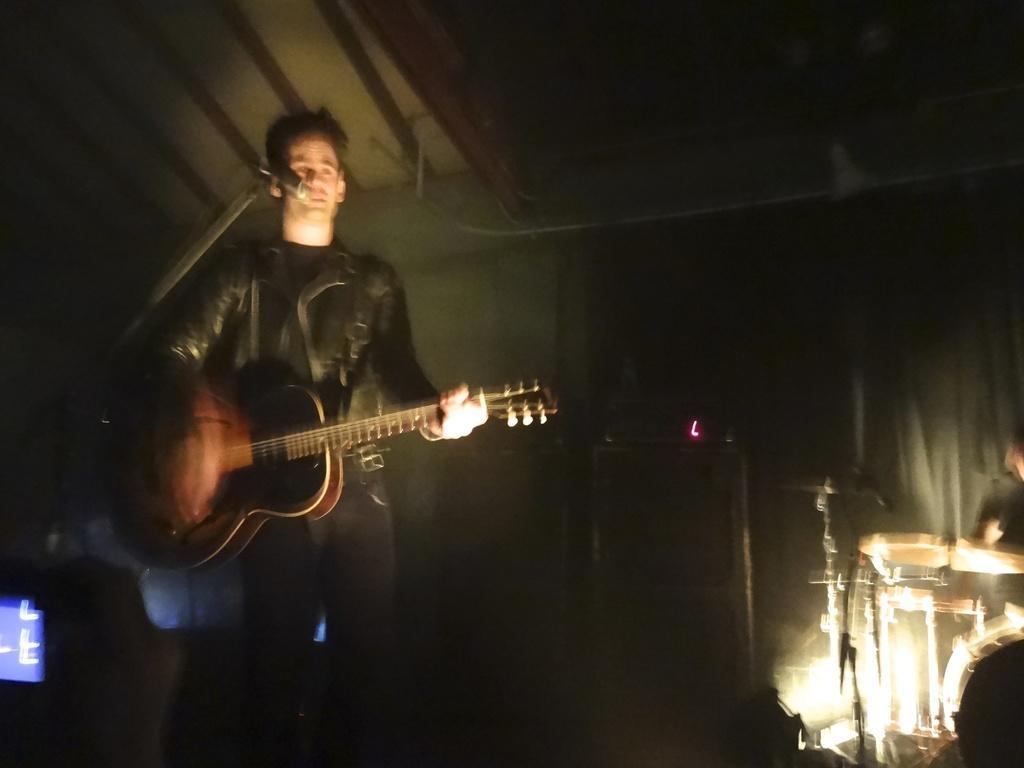How would you summarize this image in a sentence or two? This picture shows a man standing and playing guitar and microphone in front of him. 